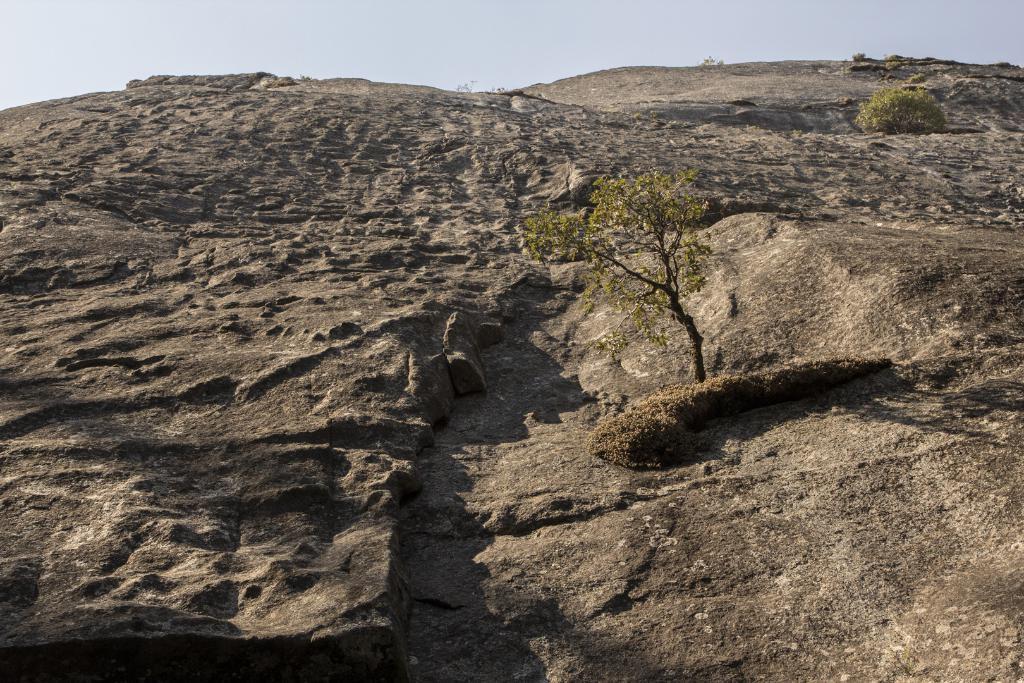Could you give a brief overview of what you see in this image? There is a rock hill. On the hill there is a tree. On the right side there is a plant. In the background there is sky. 